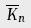Convert formula to latex. <formula><loc_0><loc_0><loc_500><loc_500>\overline { K } _ { n }</formula> 